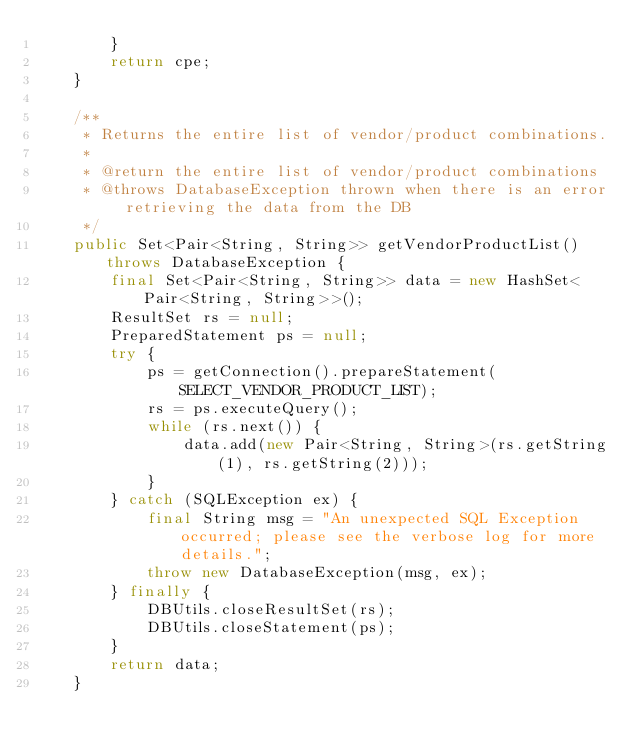<code> <loc_0><loc_0><loc_500><loc_500><_Java_>        }
        return cpe;
    }

    /**
     * Returns the entire list of vendor/product combinations.
     *
     * @return the entire list of vendor/product combinations
     * @throws DatabaseException thrown when there is an error retrieving the data from the DB
     */
    public Set<Pair<String, String>> getVendorProductList() throws DatabaseException {
        final Set<Pair<String, String>> data = new HashSet<Pair<String, String>>();
        ResultSet rs = null;
        PreparedStatement ps = null;
        try {
            ps = getConnection().prepareStatement(SELECT_VENDOR_PRODUCT_LIST);
            rs = ps.executeQuery();
            while (rs.next()) {
                data.add(new Pair<String, String>(rs.getString(1), rs.getString(2)));
            }
        } catch (SQLException ex) {
            final String msg = "An unexpected SQL Exception occurred; please see the verbose log for more details.";
            throw new DatabaseException(msg, ex);
        } finally {
            DBUtils.closeResultSet(rs);
            DBUtils.closeStatement(ps);
        }
        return data;
    }
</code> 